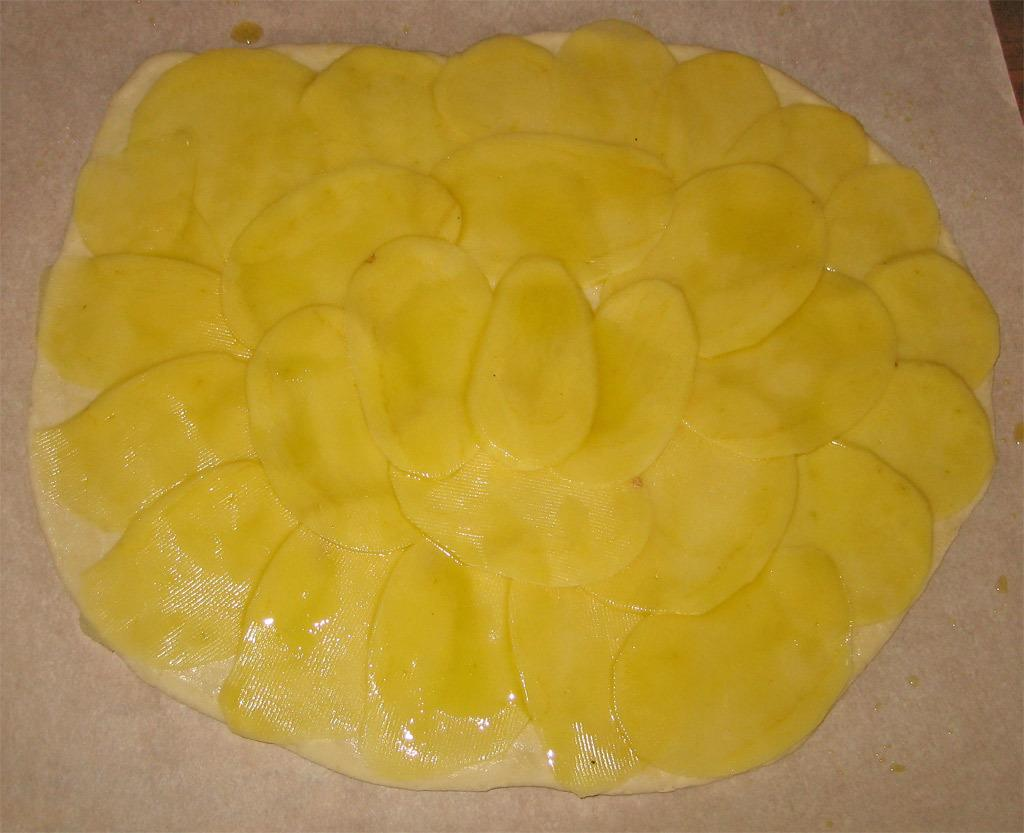What is the color of the surface in the image? The surface in the image is cream-colored. What can be seen on top of the surface? There is a yellow-colored object on the surface. How many books are stacked on the side of the yellow-colored object in the image? There are no books present in the image, and the yellow-colored object is not described as having a side. 